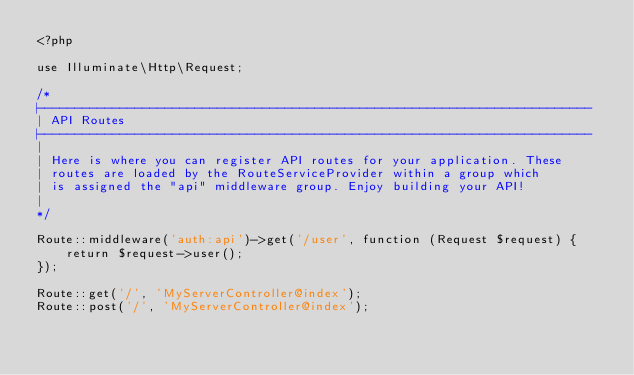Convert code to text. <code><loc_0><loc_0><loc_500><loc_500><_PHP_><?php

use Illuminate\Http\Request;

/*
|--------------------------------------------------------------------------
| API Routes
|--------------------------------------------------------------------------
|
| Here is where you can register API routes for your application. These
| routes are loaded by the RouteServiceProvider within a group which
| is assigned the "api" middleware group. Enjoy building your API!
|
*/

Route::middleware('auth:api')->get('/user', function (Request $request) {
    return $request->user();
});

Route::get('/', 'MyServerController@index');
Route::post('/', 'MyServerController@index');</code> 